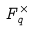Convert formula to latex. <formula><loc_0><loc_0><loc_500><loc_500>F _ { q } ^ { \times }</formula> 